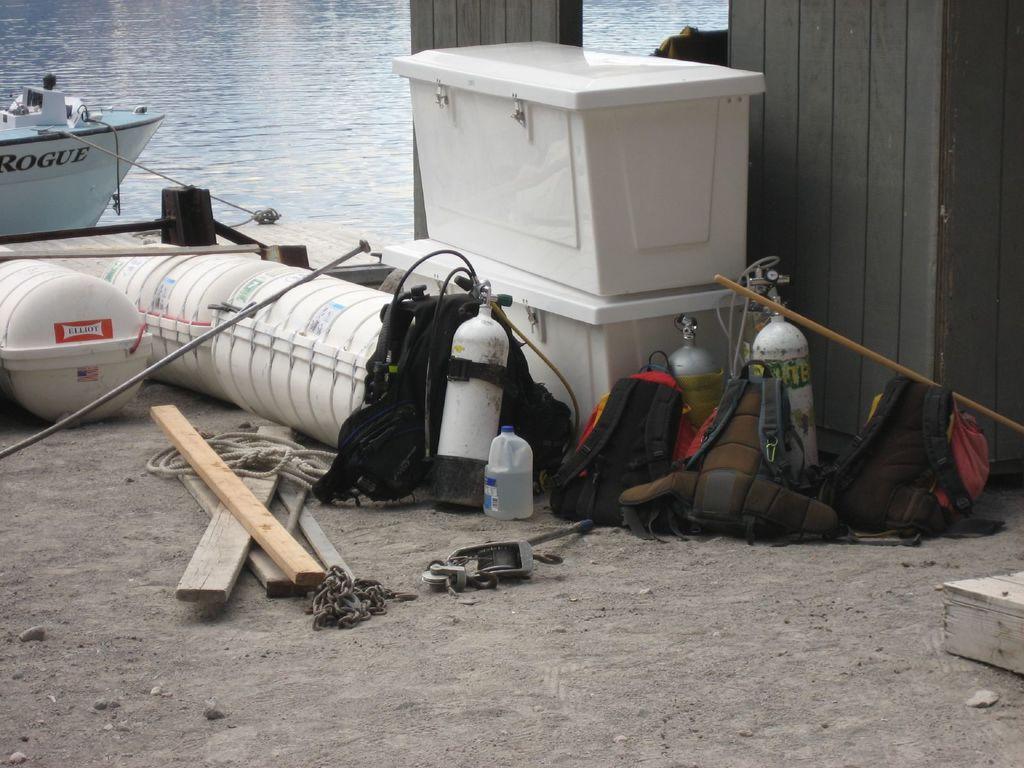Describe this image in one or two sentences. In this image we can see a boat on the surface of the water. We can also see the bags, bottle, rope, chain, wooden sticks, boxes and also some other objects. At the bottom we can see the land. 